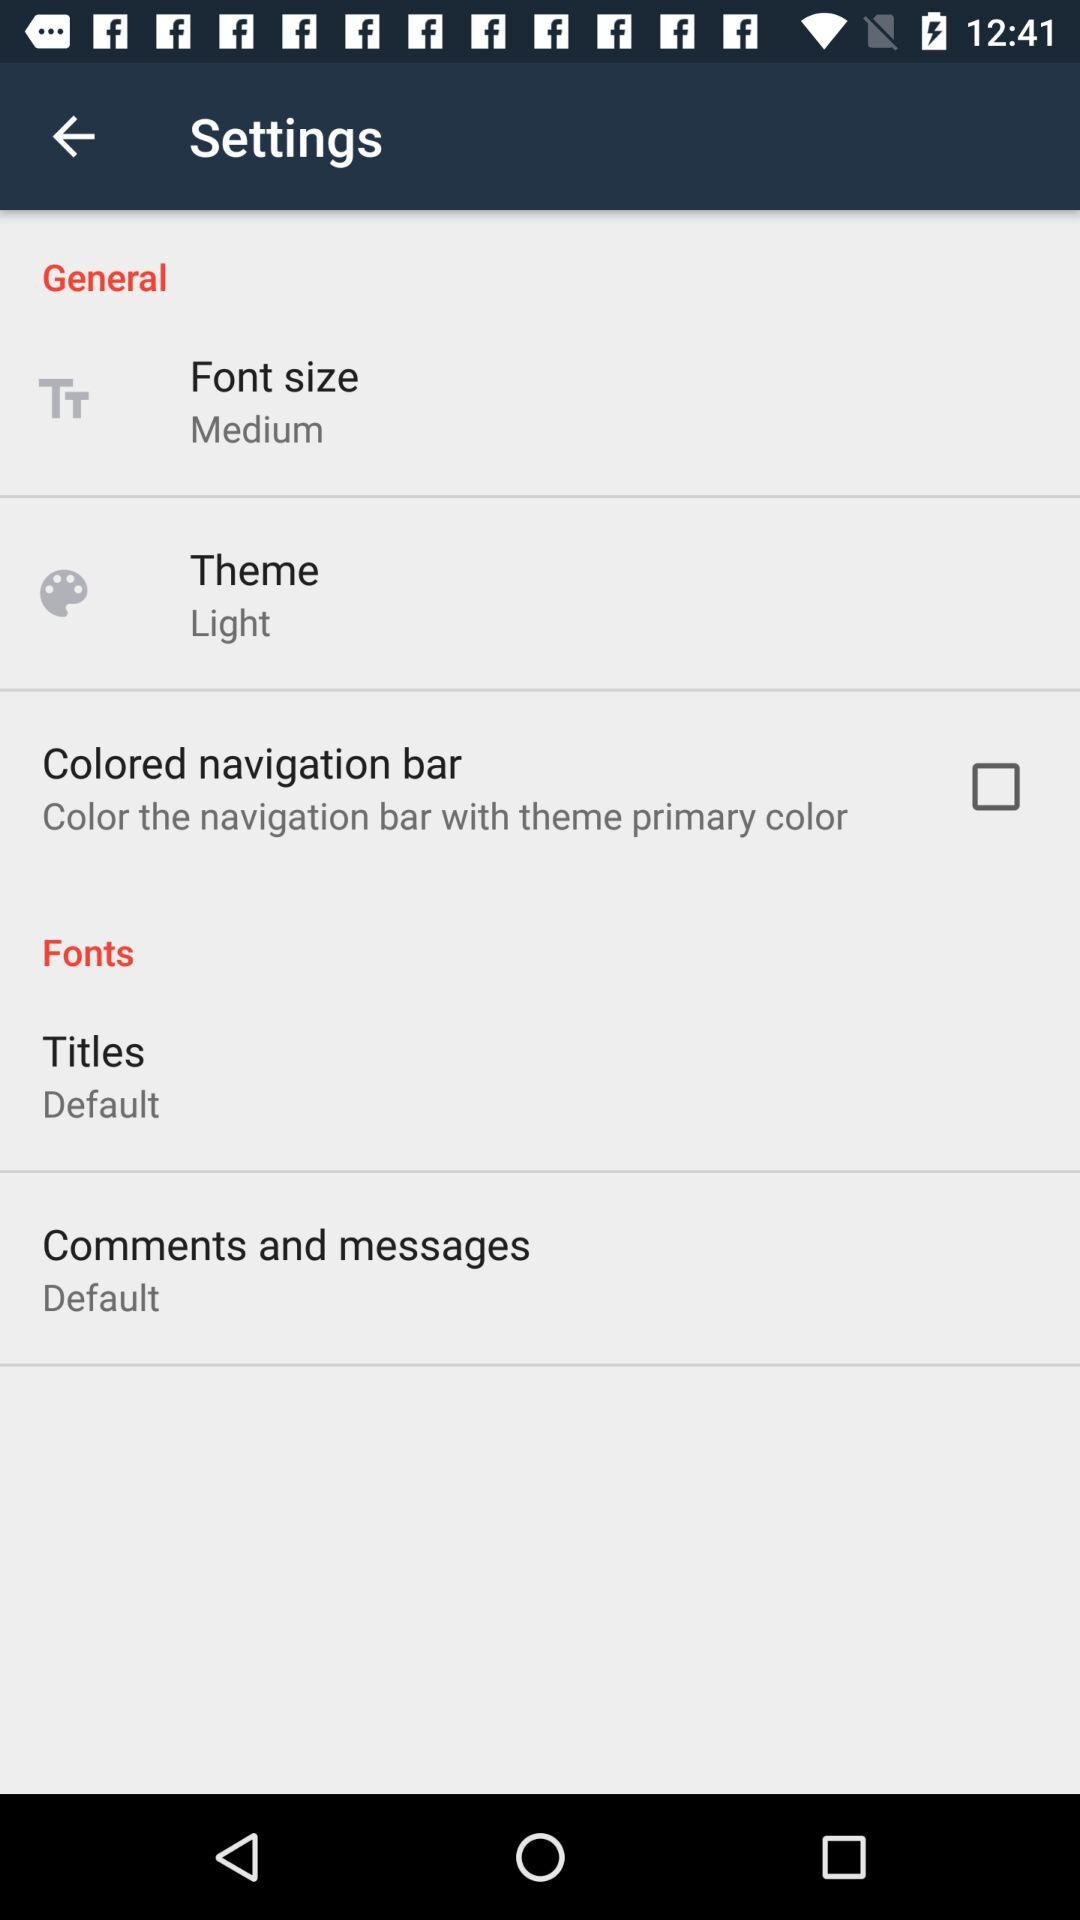What is the status of the colored navigation bar? The status is off. 